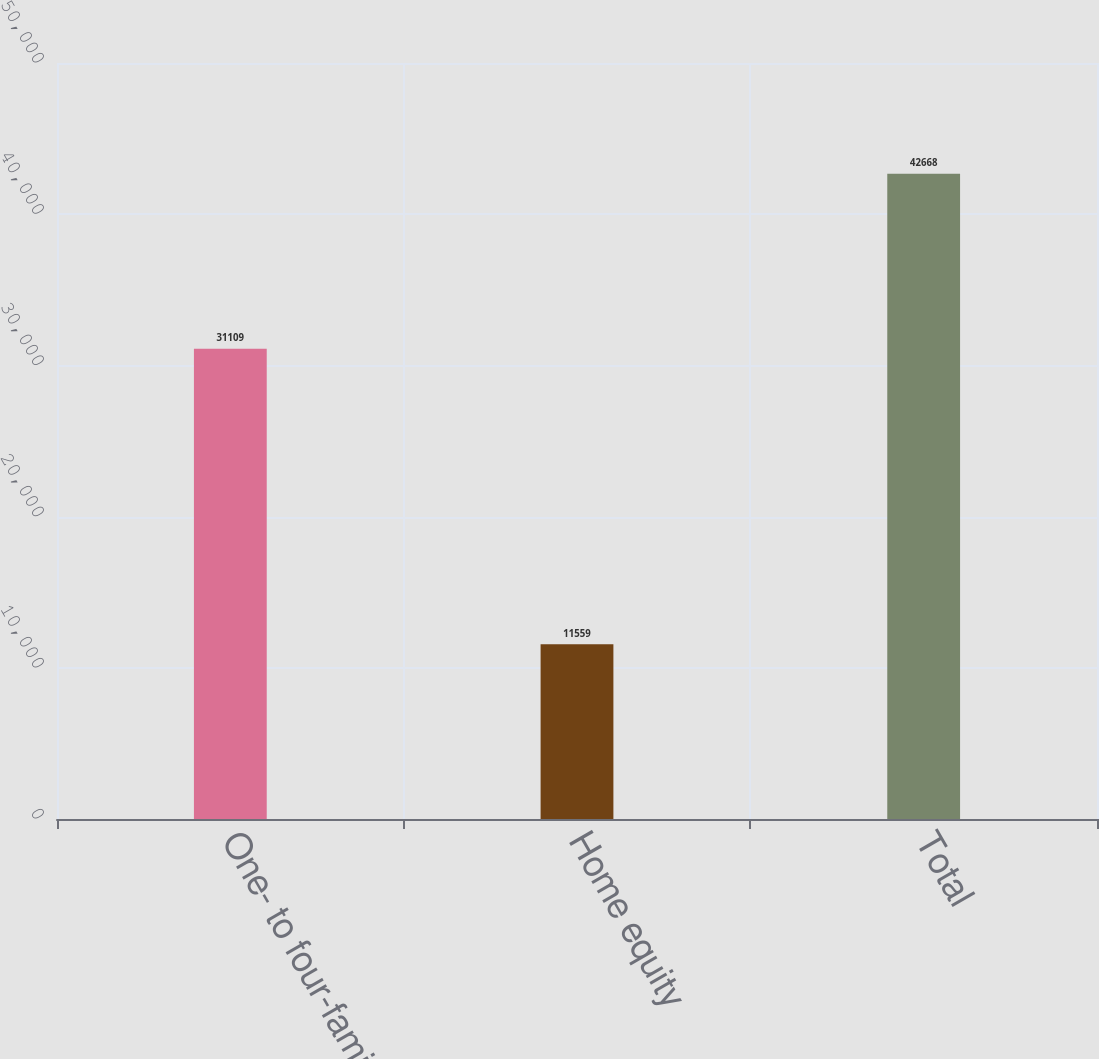<chart> <loc_0><loc_0><loc_500><loc_500><bar_chart><fcel>One- to four-family<fcel>Home equity<fcel>Total<nl><fcel>31109<fcel>11559<fcel>42668<nl></chart> 